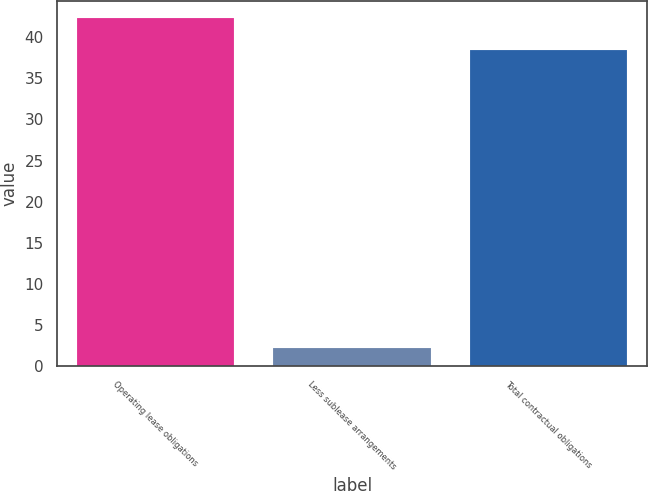<chart> <loc_0><loc_0><loc_500><loc_500><bar_chart><fcel>Operating lease obligations<fcel>Less sublease arrangements<fcel>Total contractual obligations<nl><fcel>42.31<fcel>2.2<fcel>38.5<nl></chart> 